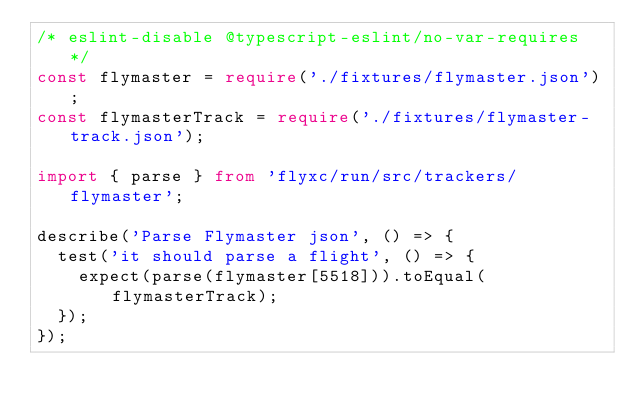<code> <loc_0><loc_0><loc_500><loc_500><_TypeScript_>/* eslint-disable @typescript-eslint/no-var-requires */
const flymaster = require('./fixtures/flymaster.json');
const flymasterTrack = require('./fixtures/flymaster-track.json');

import { parse } from 'flyxc/run/src/trackers/flymaster';

describe('Parse Flymaster json', () => {
  test('it should parse a flight', () => {
    expect(parse(flymaster[5518])).toEqual(flymasterTrack);
  });
});
</code> 